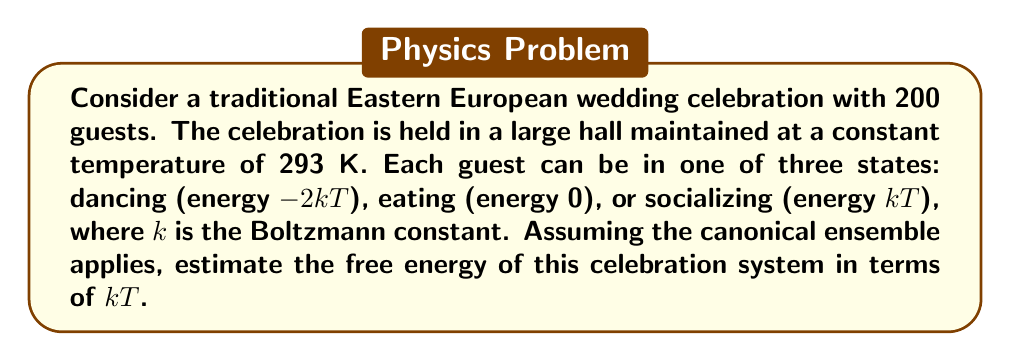Provide a solution to this math problem. Let's approach this step-by-step:

1) In the canonical ensemble, the free energy F is given by:
   $$F = -kT \ln Z$$
   where Z is the partition function.

2) For a system of N independent particles, each with partition function z, the total partition function is:
   $$Z = z^N$$

3) For each guest, the partition function z is the sum of the Boltzmann factors for each state:
   $$z = e^{2} + 1 + e^{-1}$$
   (Note: We've used $\beta = \frac{1}{kT}$ to simplify the exponents)

4) Calculate z:
   $$z = e^2 + 1 + e^{-1} \approx 8.38$$

5) Now, calculate Z:
   $$Z = (8.38)^{200}$$

6) Substitute into the free energy equation:
   $$F = -kT \ln[(8.38)^{200}]$$

7) Simplify:
   $$F = -200kT \ln(8.38)$$
   $$F \approx -425.4kT$$
Answer: $F \approx -425.4kT$ 